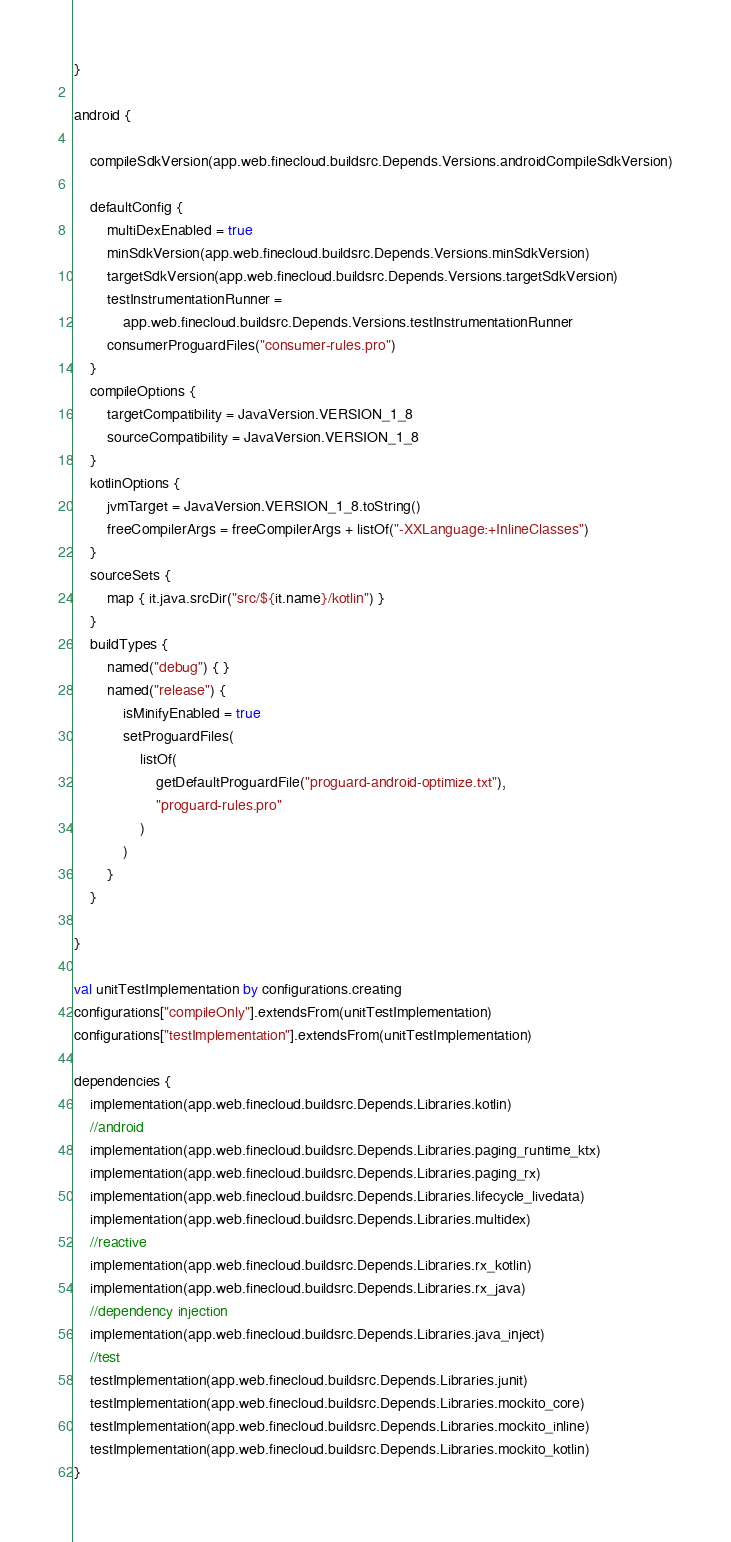<code> <loc_0><loc_0><loc_500><loc_500><_Kotlin_>}

android {

    compileSdkVersion(app.web.finecloud.buildsrc.Depends.Versions.androidCompileSdkVersion)

    defaultConfig {
        multiDexEnabled = true
        minSdkVersion(app.web.finecloud.buildsrc.Depends.Versions.minSdkVersion)
        targetSdkVersion(app.web.finecloud.buildsrc.Depends.Versions.targetSdkVersion)
        testInstrumentationRunner =
            app.web.finecloud.buildsrc.Depends.Versions.testInstrumentationRunner
        consumerProguardFiles("consumer-rules.pro")
    }
    compileOptions {
        targetCompatibility = JavaVersion.VERSION_1_8
        sourceCompatibility = JavaVersion.VERSION_1_8
    }
    kotlinOptions {
        jvmTarget = JavaVersion.VERSION_1_8.toString()
        freeCompilerArgs = freeCompilerArgs + listOf("-XXLanguage:+InlineClasses")
    }
    sourceSets {
        map { it.java.srcDir("src/${it.name}/kotlin") }
    }
    buildTypes {
        named("debug") { }
        named("release") {
            isMinifyEnabled = true
            setProguardFiles(
                listOf(
                    getDefaultProguardFile("proguard-android-optimize.txt"),
                    "proguard-rules.pro"
                )
            )
        }
    }

}

val unitTestImplementation by configurations.creating
configurations["compileOnly"].extendsFrom(unitTestImplementation)
configurations["testImplementation"].extendsFrom(unitTestImplementation)

dependencies {
    implementation(app.web.finecloud.buildsrc.Depends.Libraries.kotlin)
    //android
    implementation(app.web.finecloud.buildsrc.Depends.Libraries.paging_runtime_ktx)
    implementation(app.web.finecloud.buildsrc.Depends.Libraries.paging_rx)
    implementation(app.web.finecloud.buildsrc.Depends.Libraries.lifecycle_livedata)
    implementation(app.web.finecloud.buildsrc.Depends.Libraries.multidex)
    //reactive
    implementation(app.web.finecloud.buildsrc.Depends.Libraries.rx_kotlin)
    implementation(app.web.finecloud.buildsrc.Depends.Libraries.rx_java)
    //dependency injection
    implementation(app.web.finecloud.buildsrc.Depends.Libraries.java_inject)
    //test
    testImplementation(app.web.finecloud.buildsrc.Depends.Libraries.junit)
    testImplementation(app.web.finecloud.buildsrc.Depends.Libraries.mockito_core)
    testImplementation(app.web.finecloud.buildsrc.Depends.Libraries.mockito_inline)
    testImplementation(app.web.finecloud.buildsrc.Depends.Libraries.mockito_kotlin)
}</code> 